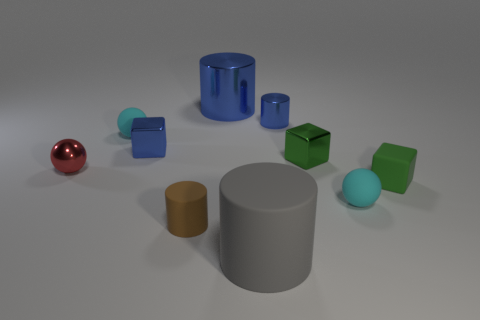Are there fewer tiny green cubes that are on the left side of the big blue shiny cylinder than gray cylinders that are to the left of the small blue cube?
Provide a short and direct response. No. There is another small metal object that is the same shape as the small brown thing; what is its color?
Keep it short and to the point. Blue. What is the size of the brown rubber cylinder?
Offer a very short reply. Small. What number of green matte cubes have the same size as the green metal cube?
Your response must be concise. 1. Does the large shiny cylinder have the same color as the small shiny cylinder?
Your answer should be compact. Yes. Is the tiny cylinder that is left of the big gray rubber cylinder made of the same material as the small cyan sphere that is left of the large blue cylinder?
Keep it short and to the point. Yes. Is the number of big gray cylinders greater than the number of tiny cubes?
Your answer should be very brief. No. Are there any other things that are the same color as the tiny metal sphere?
Your answer should be very brief. No. Are the blue block and the tiny red thing made of the same material?
Provide a short and direct response. Yes. Is the number of large brown cylinders less than the number of tiny blue cubes?
Offer a very short reply. Yes. 